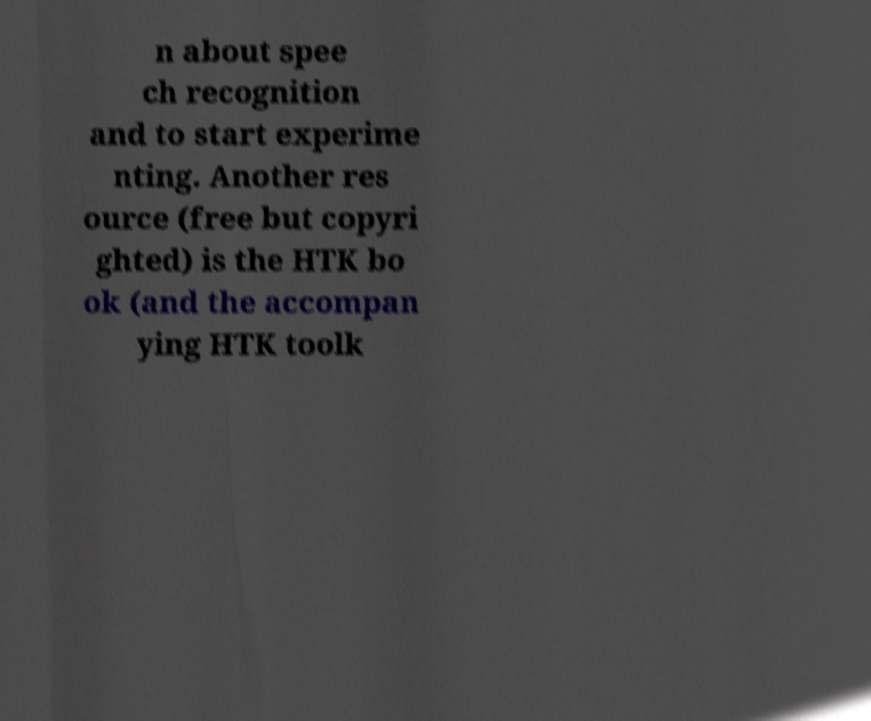There's text embedded in this image that I need extracted. Can you transcribe it verbatim? n about spee ch recognition and to start experime nting. Another res ource (free but copyri ghted) is the HTK bo ok (and the accompan ying HTK toolk 